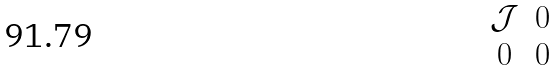Convert formula to latex. <formula><loc_0><loc_0><loc_500><loc_500>\begin{matrix} \mathcal { J } & 0 \\ 0 & 0 \end{matrix}</formula> 